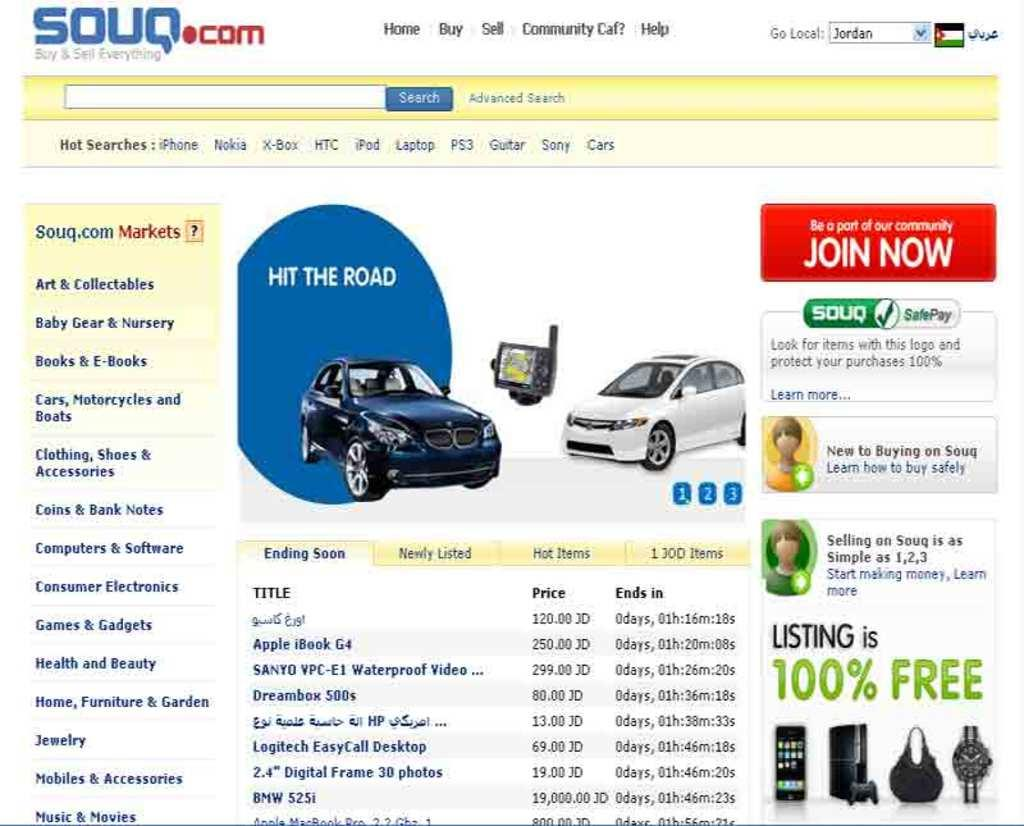What is the main subject of the advertisement in the image? The advertisement is about cars. What else is included in the advertisement besides cars? The advertisement includes other items for buying and selling. What type of juice can be seen bursting out of the island in the image? There is no juice or island present in the image; it features an advertisement about cars and other items for buying and selling. 